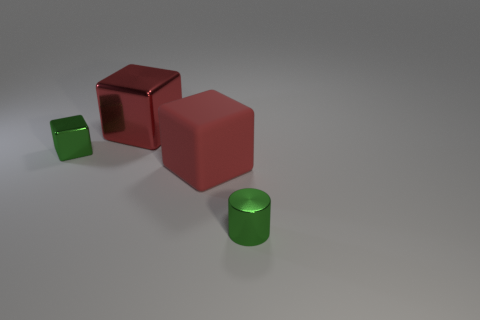Add 3 rubber cubes. How many objects exist? 7 Subtract all red cubes. How many cubes are left? 1 Add 1 tiny brown shiny spheres. How many tiny brown shiny spheres exist? 1 Subtract all green cubes. How many cubes are left? 2 Subtract 0 blue cylinders. How many objects are left? 4 Subtract all blocks. How many objects are left? 1 Subtract all brown blocks. Subtract all gray spheres. How many blocks are left? 3 Subtract all cyan spheres. How many red blocks are left? 2 Subtract all large gray matte things. Subtract all tiny metallic things. How many objects are left? 2 Add 4 big red things. How many big red things are left? 6 